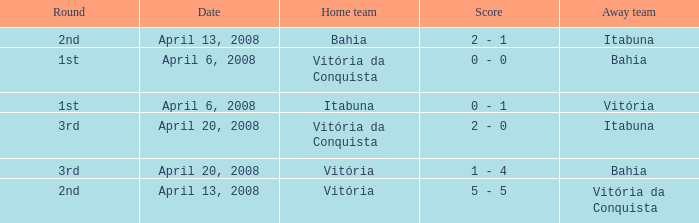On which date was the score 0 - 0? April 6, 2008. Parse the full table. {'header': ['Round', 'Date', 'Home team', 'Score', 'Away team'], 'rows': [['2nd', 'April 13, 2008', 'Bahia', '2 - 1', 'Itabuna'], ['1st', 'April 6, 2008', 'Vitória da Conquista', '0 - 0', 'Bahia'], ['1st', 'April 6, 2008', 'Itabuna', '0 - 1', 'Vitória'], ['3rd', 'April 20, 2008', 'Vitória da Conquista', '2 - 0', 'Itabuna'], ['3rd', 'April 20, 2008', 'Vitória', '1 - 4', 'Bahia'], ['2nd', 'April 13, 2008', 'Vitória', '5 - 5', 'Vitória da Conquista']]} 